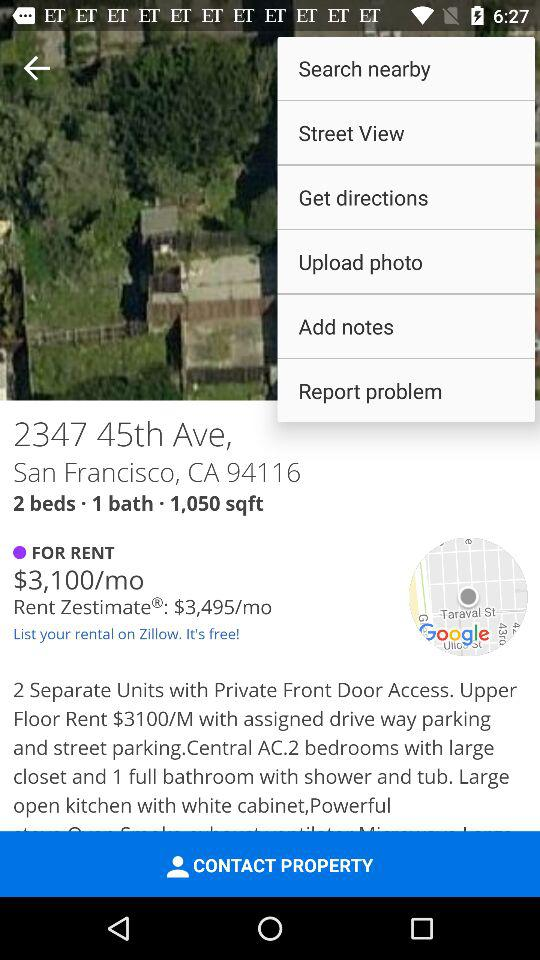What is the name of the application? The application name is "Zillow". 